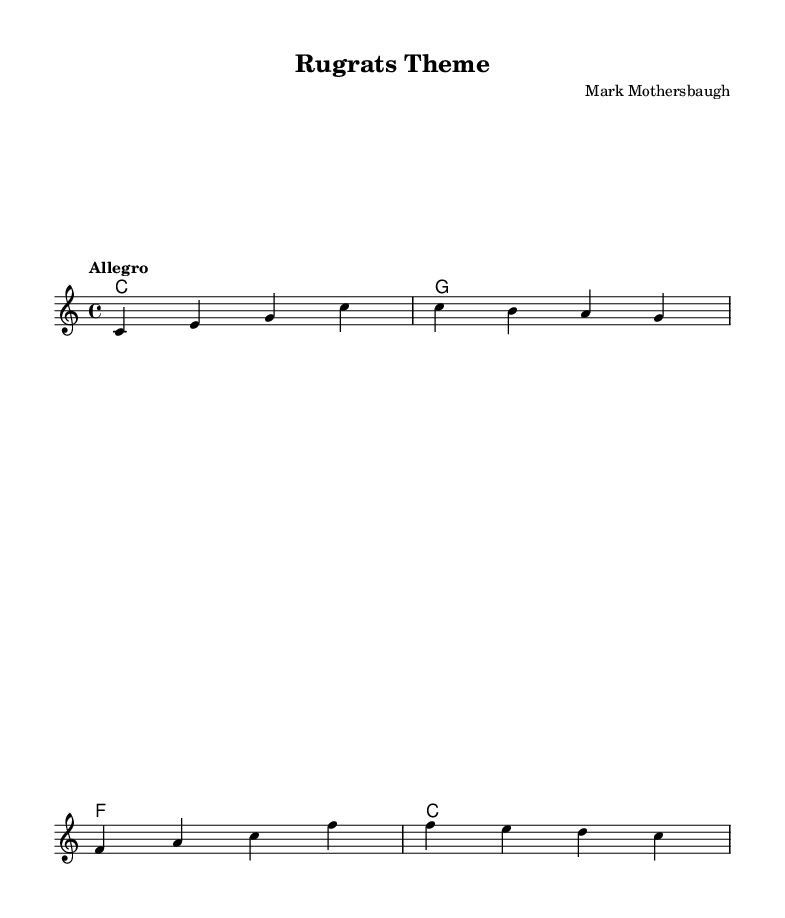What is the key signature of this music? The key signature is C major, which is indicated in the global section of the code. This key has no sharps or flats.
Answer: C major What is the time signature of this music? The time signature is indicated as 4/4 in the global section of the code. This means there are four beats in each measure.
Answer: 4/4 What is the tempo marking for this piece? The tempo marking is "Allegro," as stated in the global section of the code, indicating a fast and lively pace.
Answer: Allegro How many measures are in the melody section? By counting the number of distinct musical statements separated by vertical lines in the melody section of the code, there are four measures.
Answer: 4 What is the first note of the melody? The first note of the melody is "C," which is the first note in the sequence provided in the relative section of the code.
Answer: C What chord is played in the last measure? The last measure contains the chord "C," which is specified in the harmonies section of the code, indicating what accompaniment is played underneath.
Answer: C How many different chords are used in the piece? There are four distinct chords used in total, as indicated by the chord listings in the harmonies section of the code: C, G, F, and another C.
Answer: 4 